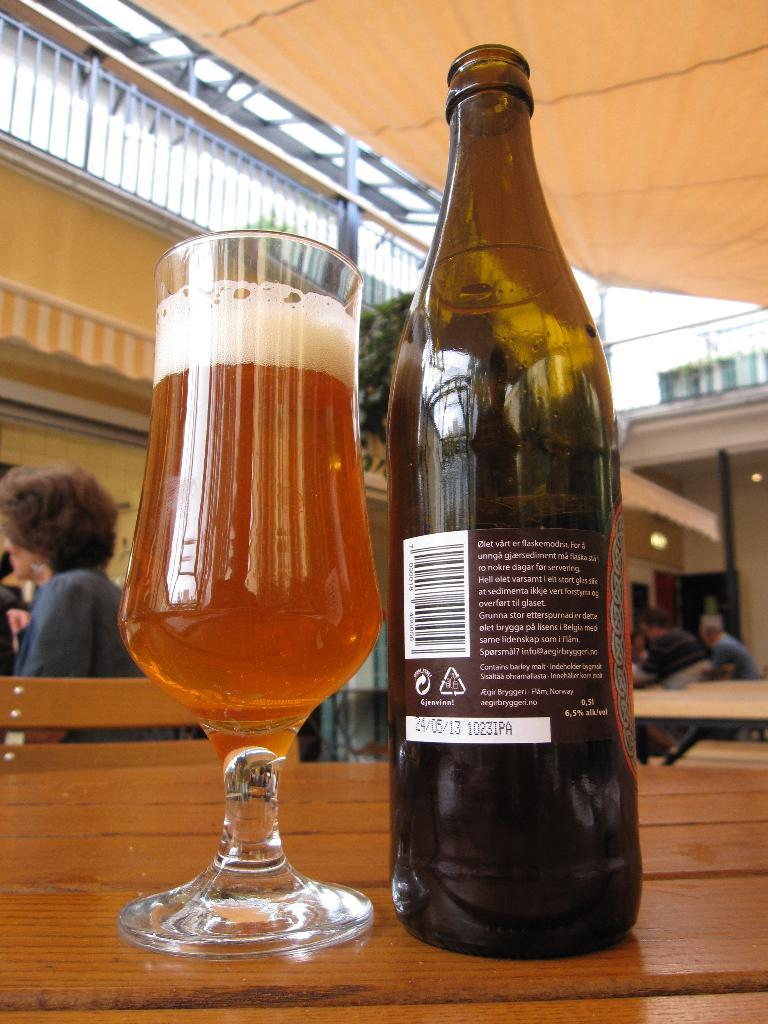<image>
Provide a brief description of the given image. the country of Norway mentioned on a beer bottle 